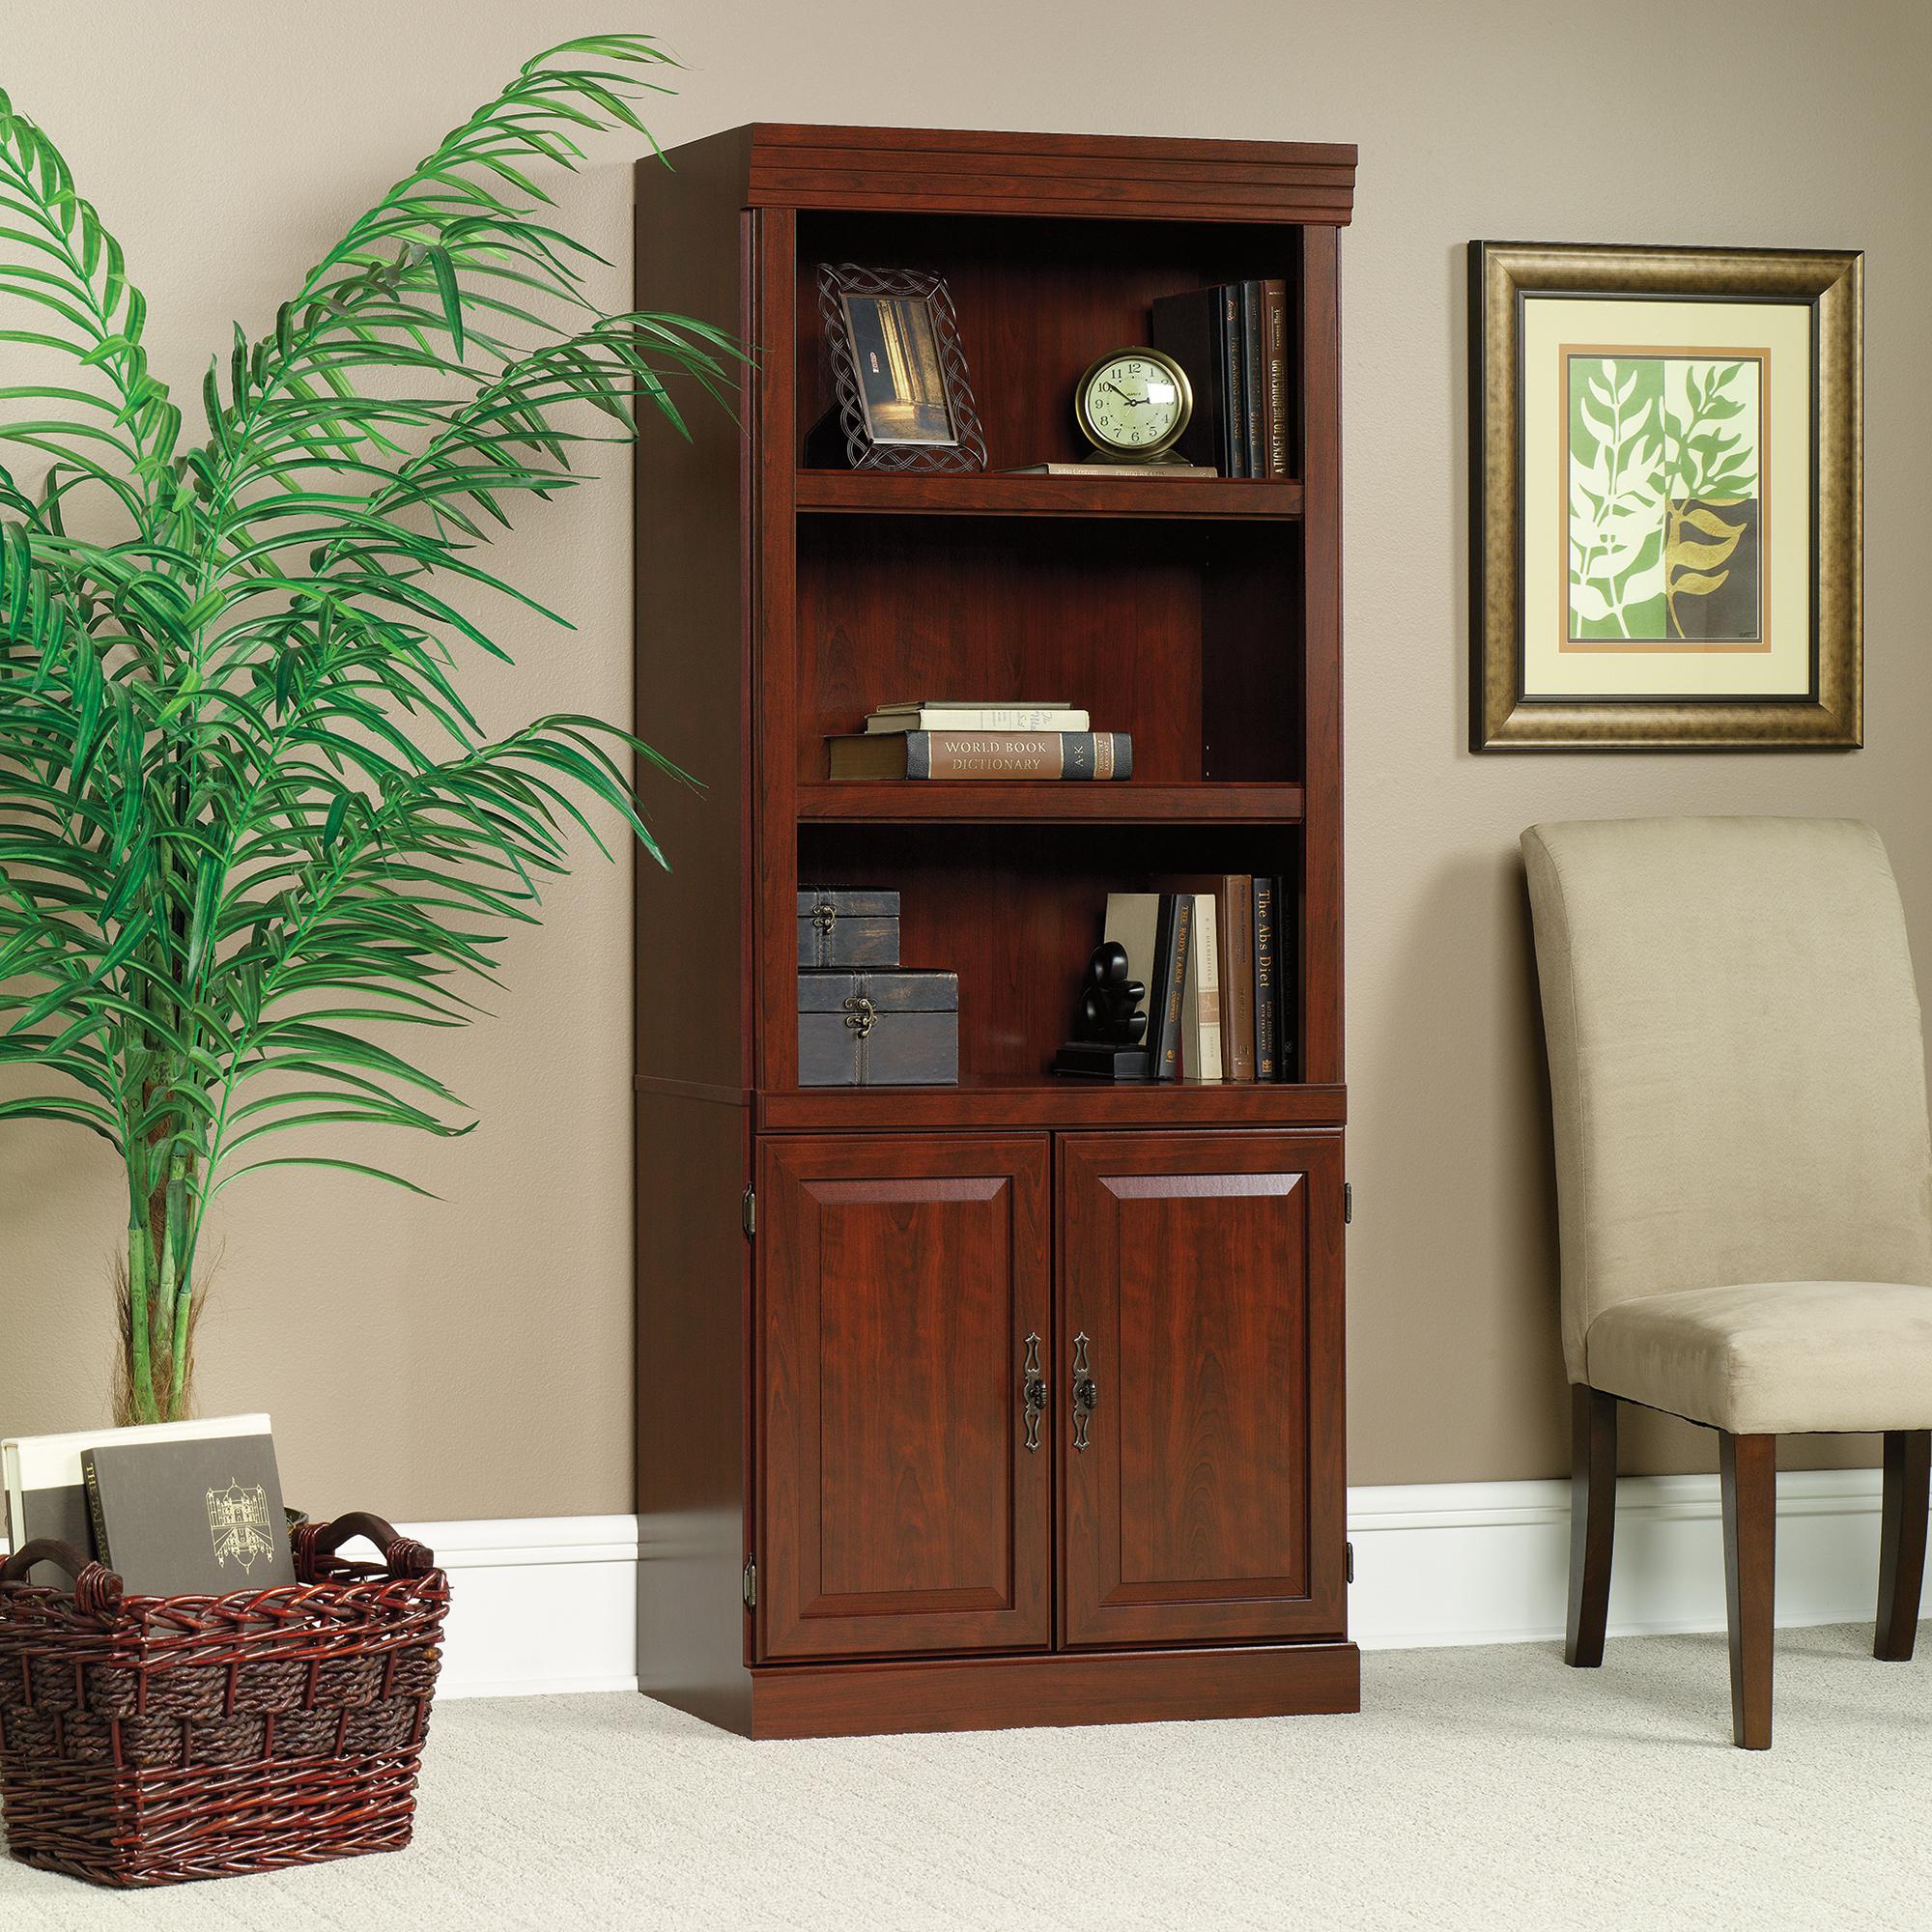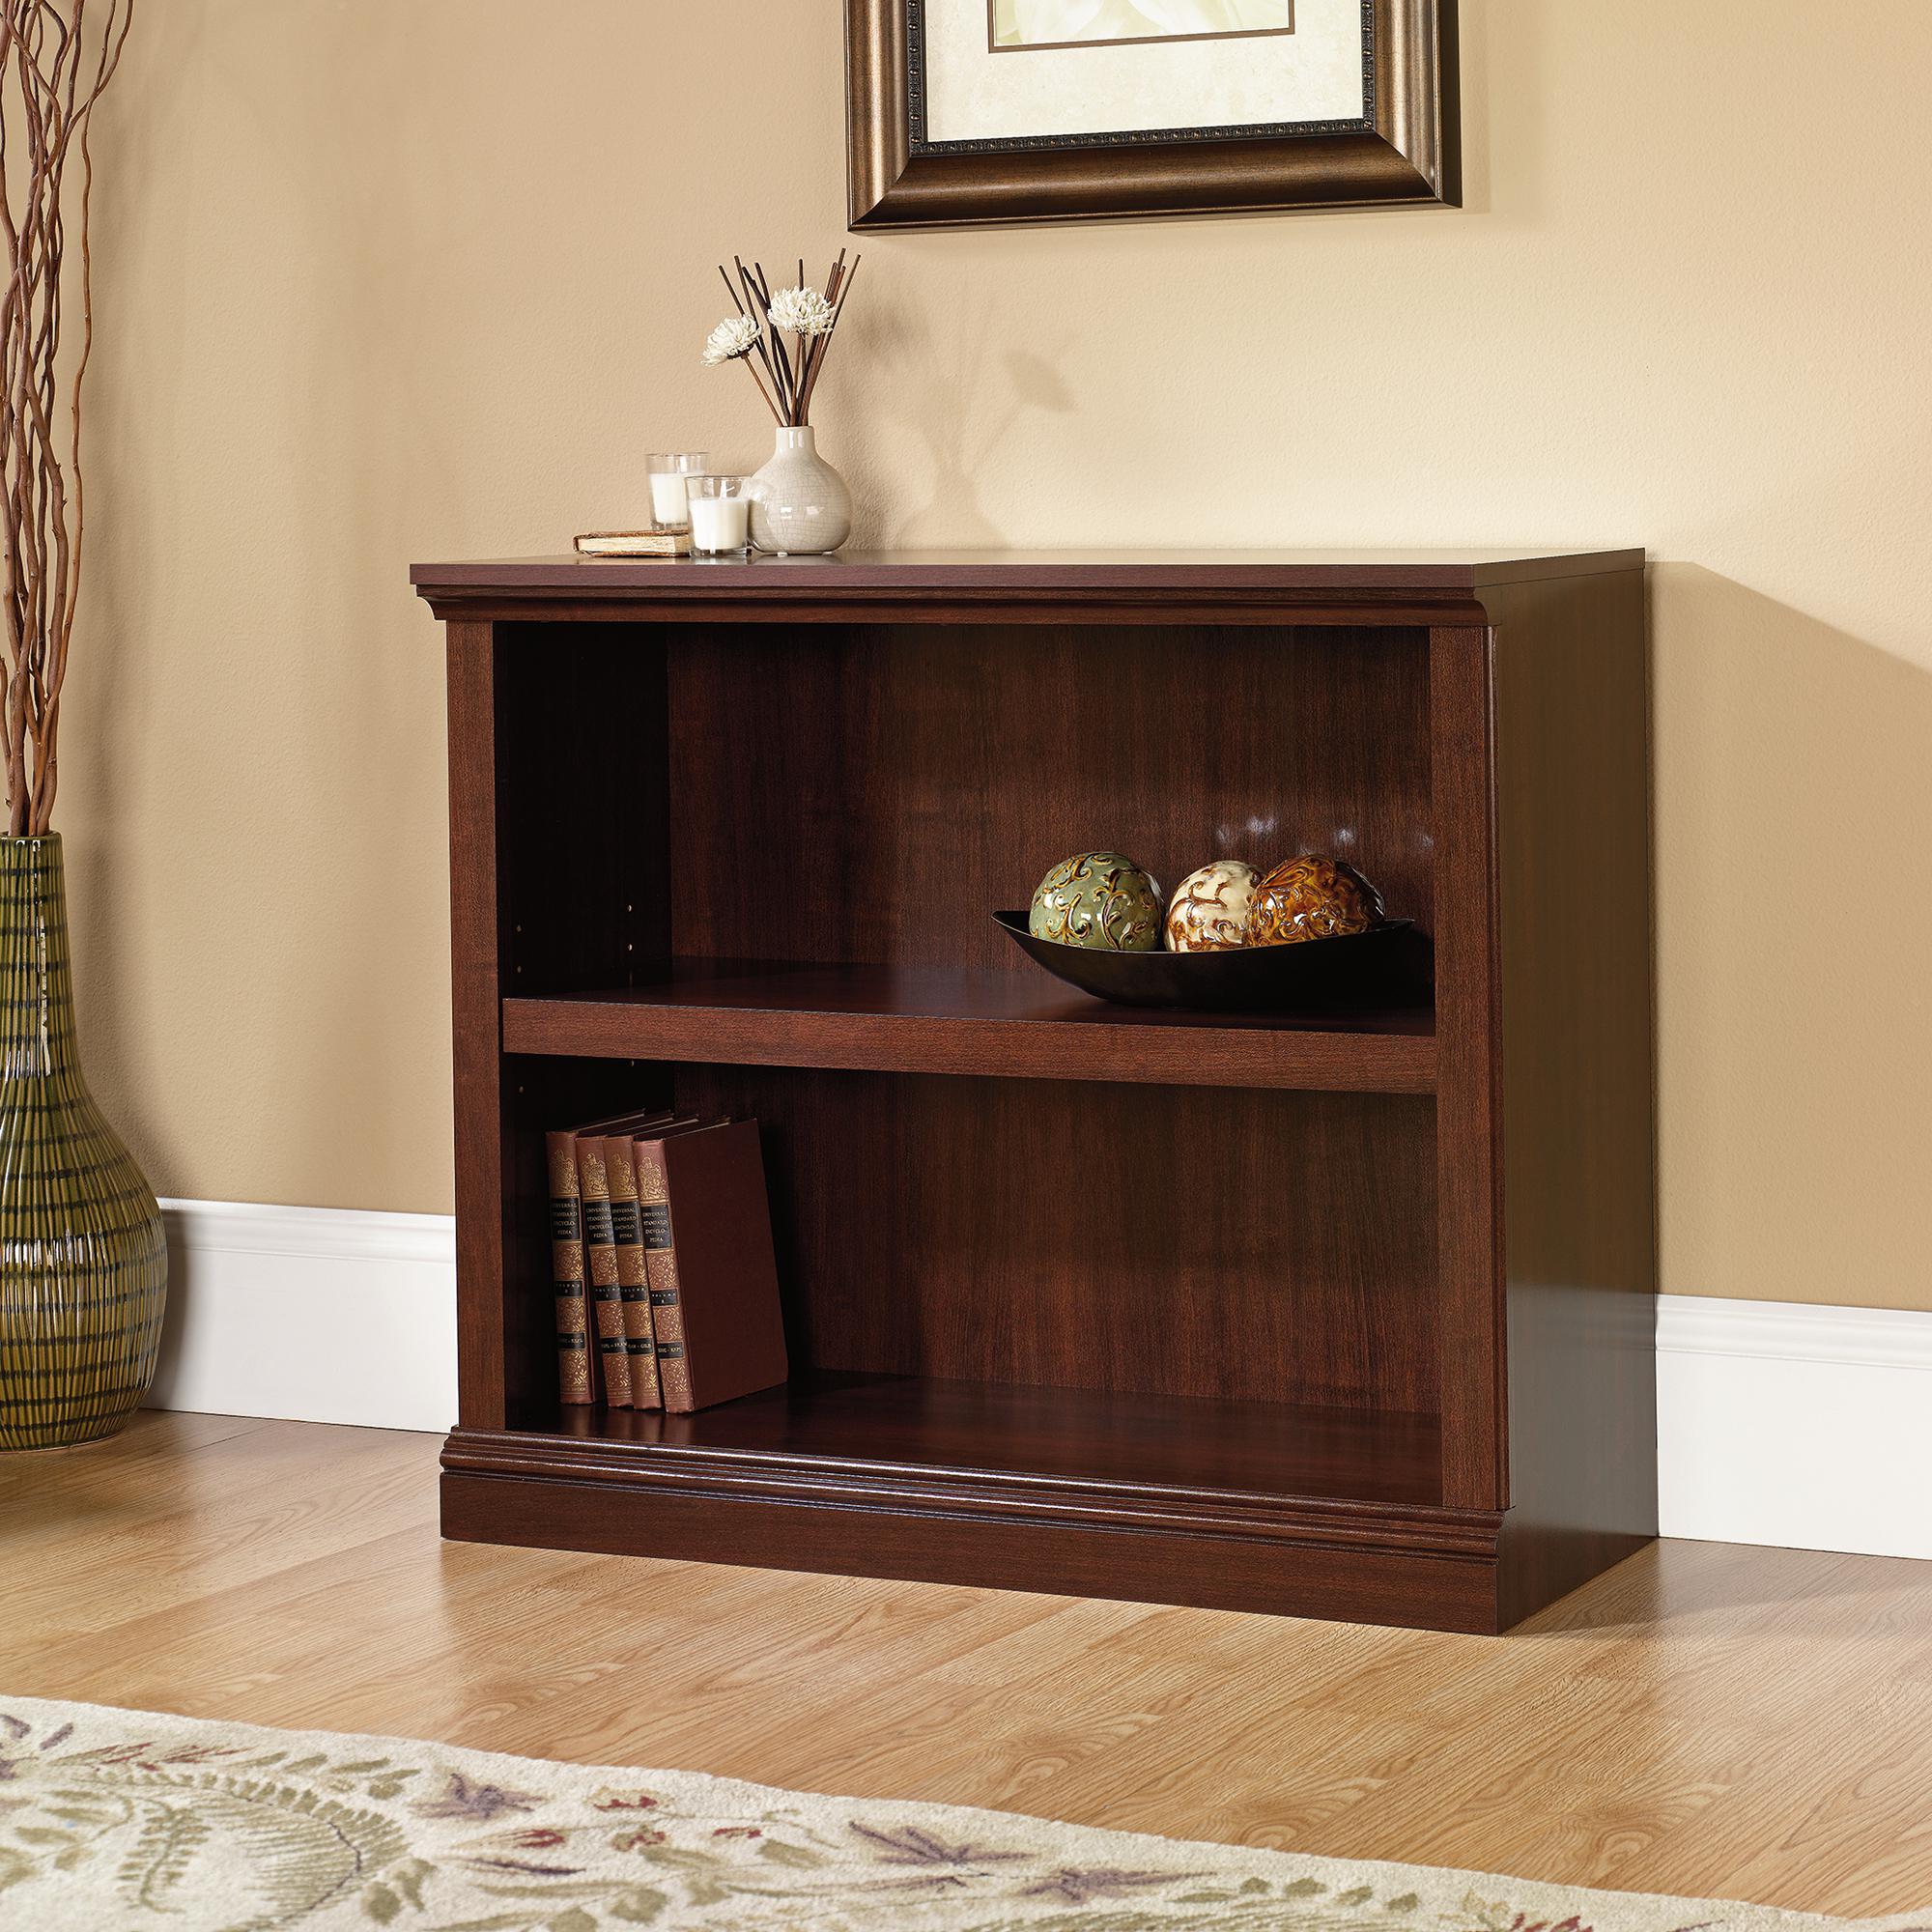The first image is the image on the left, the second image is the image on the right. Analyze the images presented: Is the assertion "Both bookcases have three shelves." valid? Answer yes or no. No. The first image is the image on the left, the second image is the image on the right. Assess this claim about the two images: "Each bookcase has a solid back and exactly three shelves, and one bookcase has two items side-by-side on its top, while the other has an empty top.". Correct or not? Answer yes or no. No. 